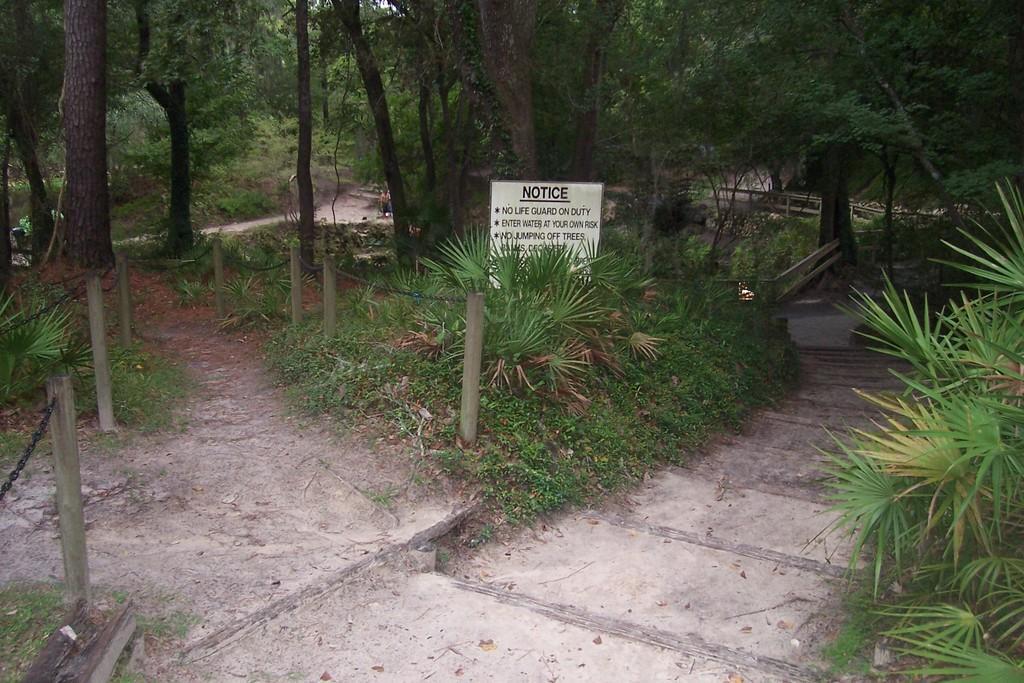Could you give a brief overview of what you see in this image? In the picture it looks like a park, there are many trees and grass all over and in between the grass there is a path to walk. 